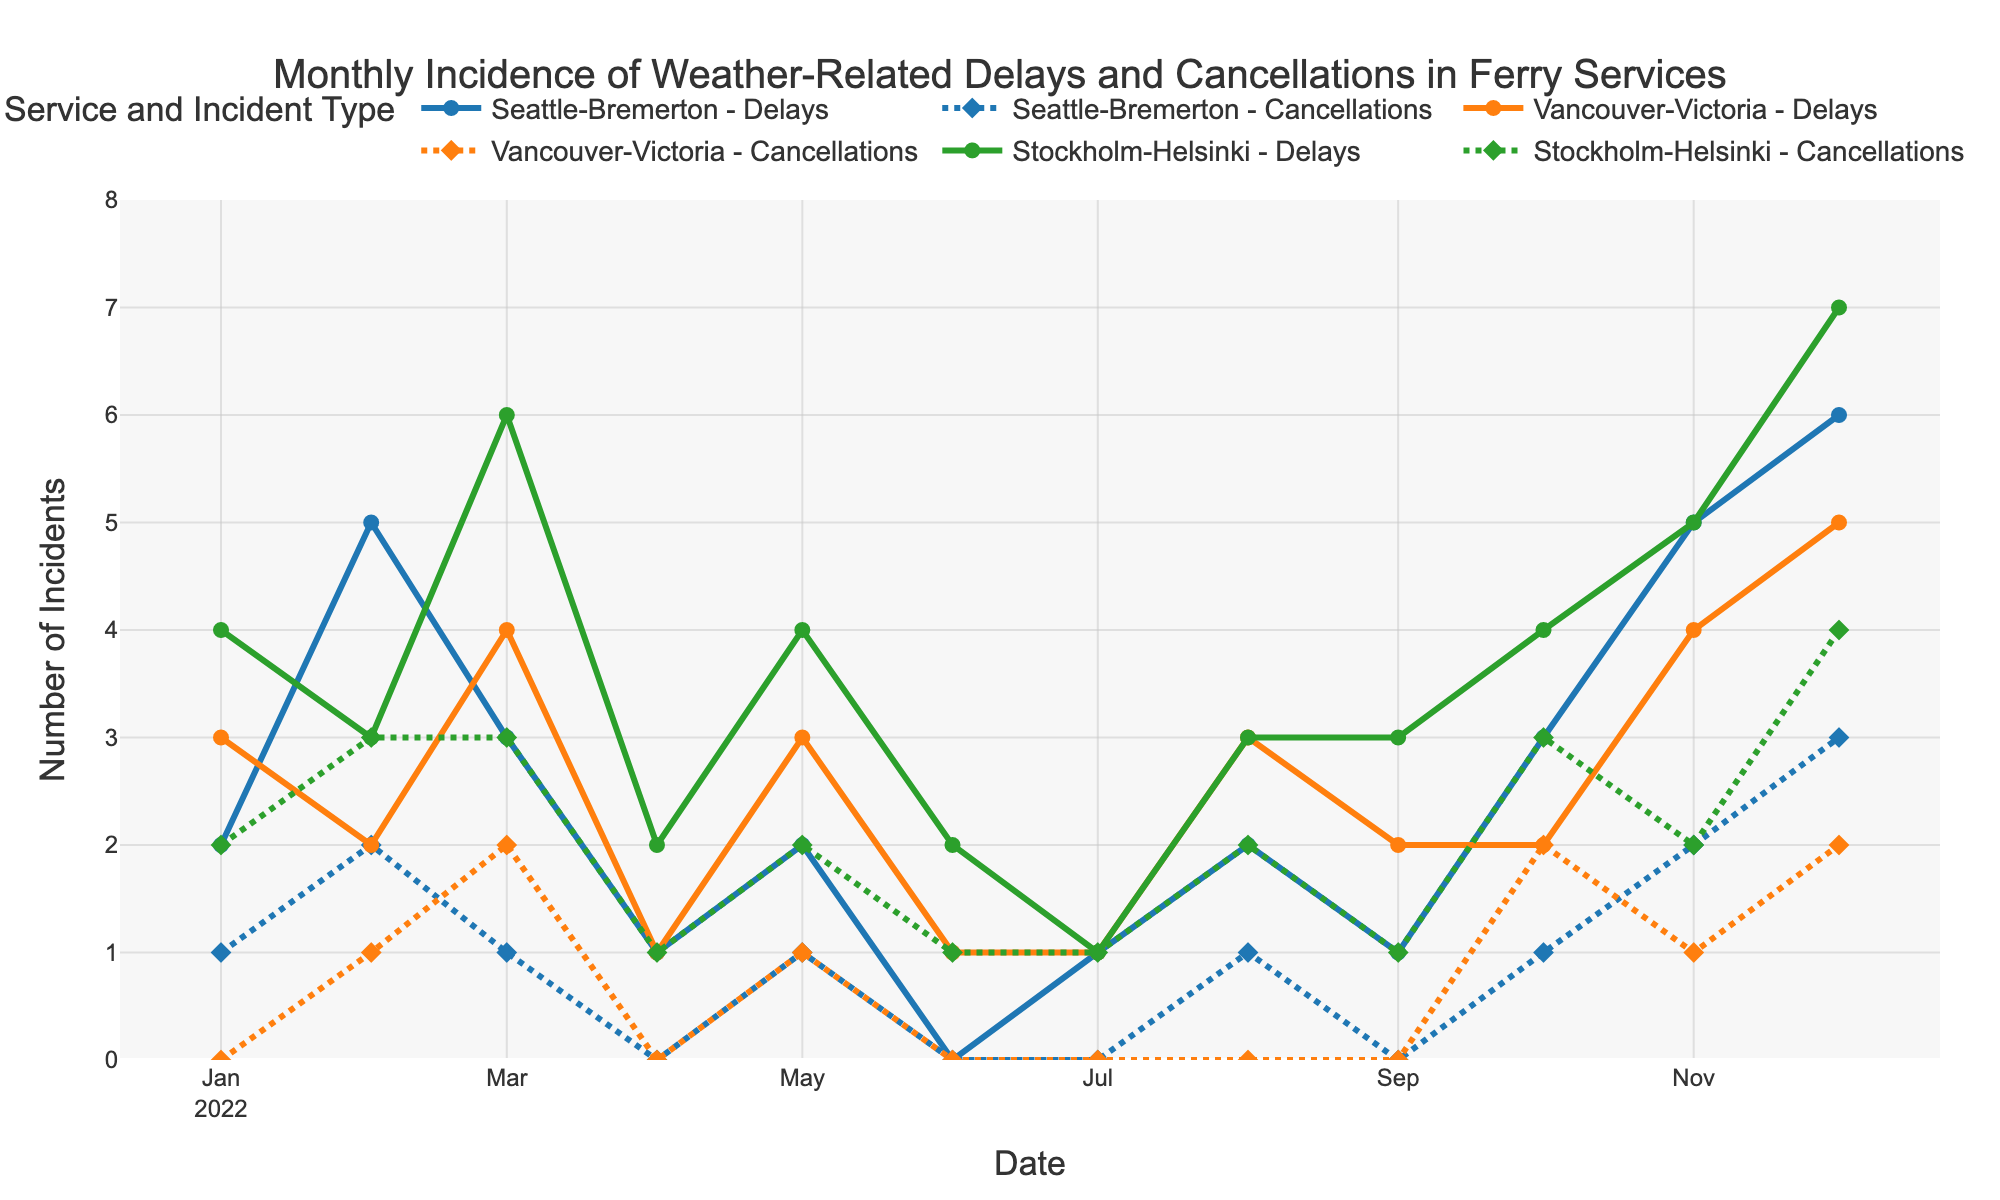What is the title of the figure? The title is written at the top of the figure. It is given in the text.
Answer: Monthly Incidence of Weather-Related Delays and Cancellations in Ferry Services What are the three services shown in the figure? The services are represented by different lines and colors in the figure legend.
Answer: Seattle-Bremerton, Vancouver-Victoria, Stockholm-Helsinki Which service had the highest number of delays in December 2022? Look at the December 2022 data points for each service and check which has the highest value in the 'Delays' lines.
Answer: Stockholm-Helsinki How many weather-related cancellations occurred for the Seattle-Bremerton service in July 2022? Find the data point for Seattle-Bremerton in July 2022 and look at the 'Cancellations' value.
Answer: 0 Which month saw the highest number of delays across all services? Check each month's total delays for all services combined and identify the month with the highest value.
Answer: December 2022 Compare the number of cancellations in February between Vancouver-Victoria and Stockholm-Helsinki. Which service had more cancellations? Look at the 'Cancellations' data points for both services in February and compare them.
Answer: Stockholm-Helsinki What is the general trend of delays for the Stockholm-Helsinki service from January to December 2022? Observe the pattern of the 'Delays' line for Stockholm-Helsinki across the months. Describe if it increases, decreases, or fluctuates.
Answer: Generally increasing What was the total number of cancellations for all services in May 2022? Add the 'Cancellations' values for all three services in May 2022.
Answer: 4 During which month(s) did the Seattle-Bremerton service experience no delays or cancellations? Check the 'Delays' and 'Cancellations' data points for Seattle-Bremerton to identify the month(s) with zero values.
Answer: June 2022 Is there any month where Vancouver-Victoria had both zero delays and zero cancellations? Review the 'Delays' and 'Cancellations' data points for Vancouver-Victoria to find any month with both values as zero.
Answer: No 